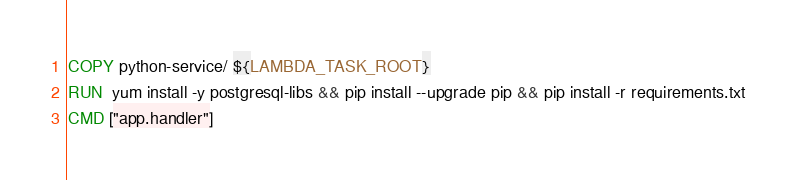Convert code to text. <code><loc_0><loc_0><loc_500><loc_500><_Dockerfile_>
COPY python-service/ ${LAMBDA_TASK_ROOT}
RUN  yum install -y postgresql-libs && pip install --upgrade pip && pip install -r requirements.txt
CMD ["app.handler"]
</code> 